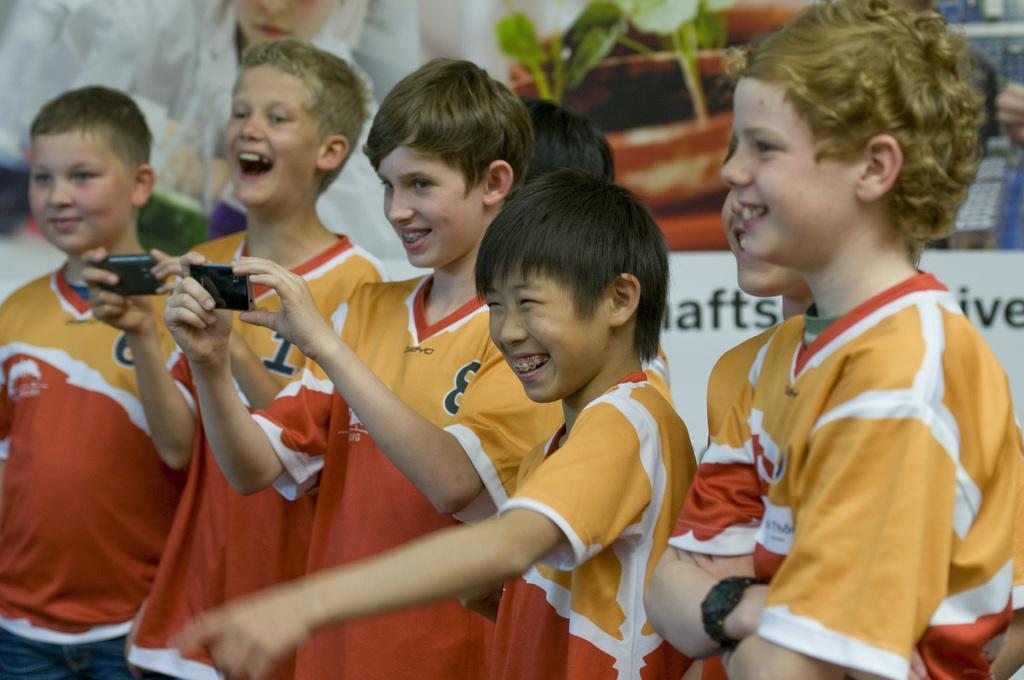<image>
Create a compact narrative representing the image presented. Young boys are smiling are wearing orange jerseys with numbers on them such as 1. 